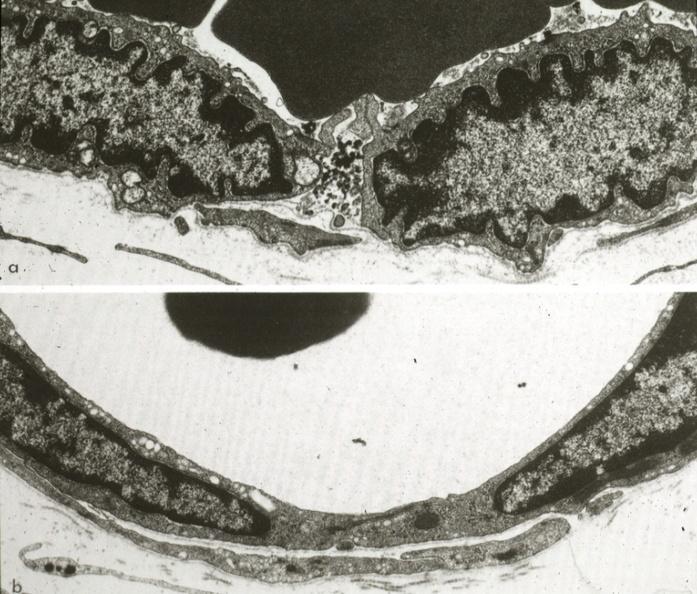what is present?
Answer the question using a single word or phrase. Capillary 